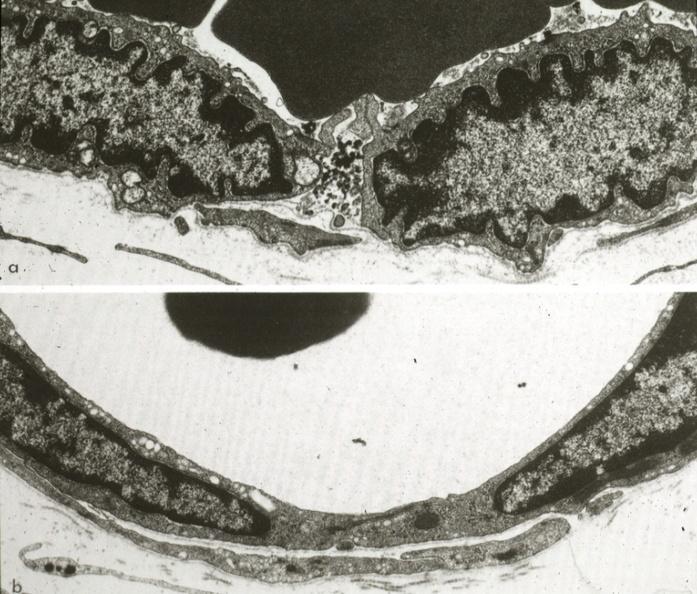what is present?
Answer the question using a single word or phrase. Capillary 